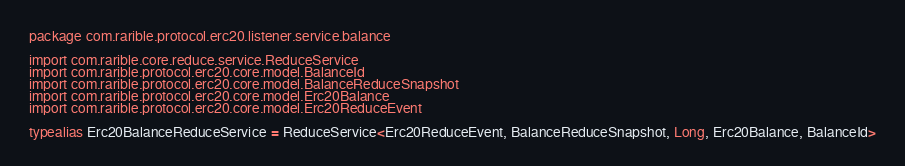Convert code to text. <code><loc_0><loc_0><loc_500><loc_500><_Kotlin_>package com.rarible.protocol.erc20.listener.service.balance

import com.rarible.core.reduce.service.ReduceService
import com.rarible.protocol.erc20.core.model.BalanceId
import com.rarible.protocol.erc20.core.model.BalanceReduceSnapshot
import com.rarible.protocol.erc20.core.model.Erc20Balance
import com.rarible.protocol.erc20.core.model.Erc20ReduceEvent

typealias Erc20BalanceReduceService = ReduceService<Erc20ReduceEvent, BalanceReduceSnapshot, Long, Erc20Balance, BalanceId>
</code> 